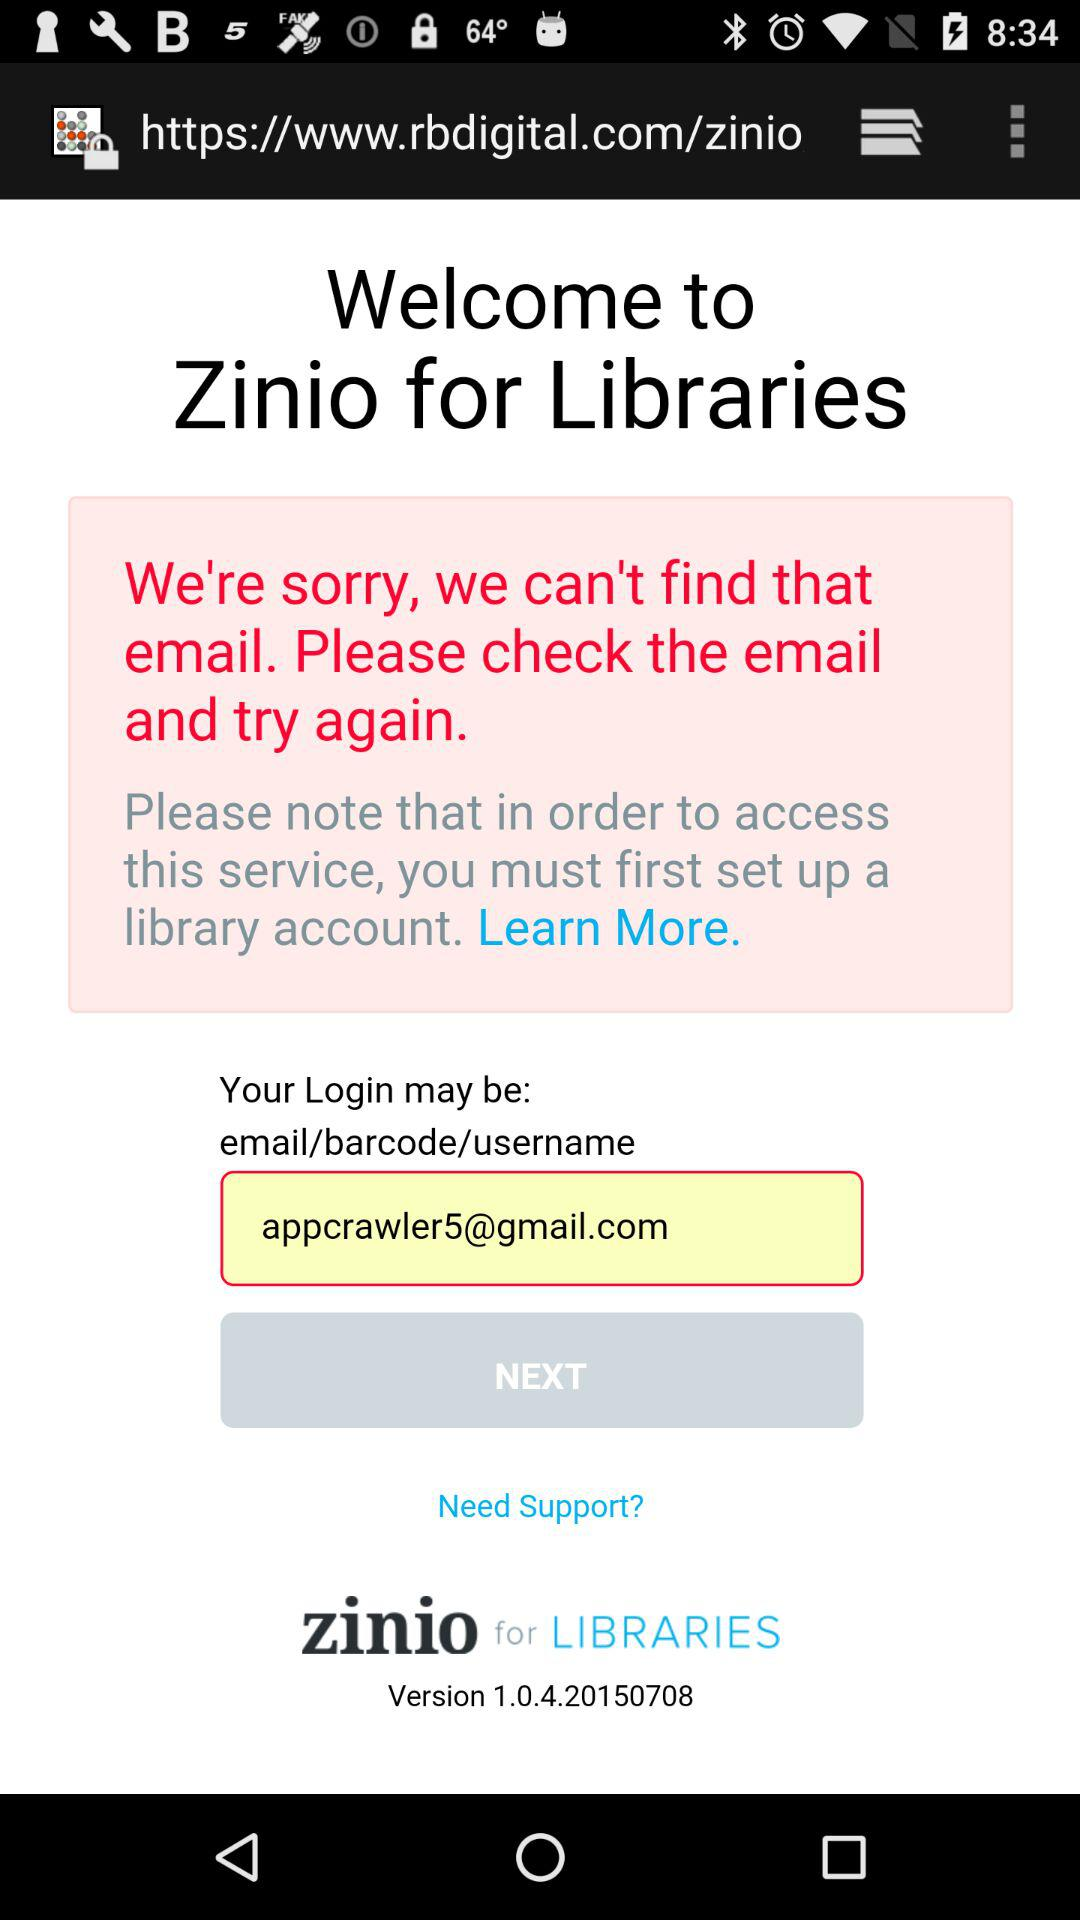What is the name of the application? The name of the application is "Zinio for Libraries". 